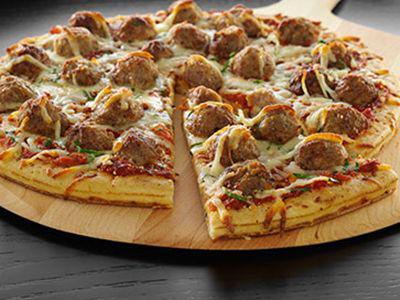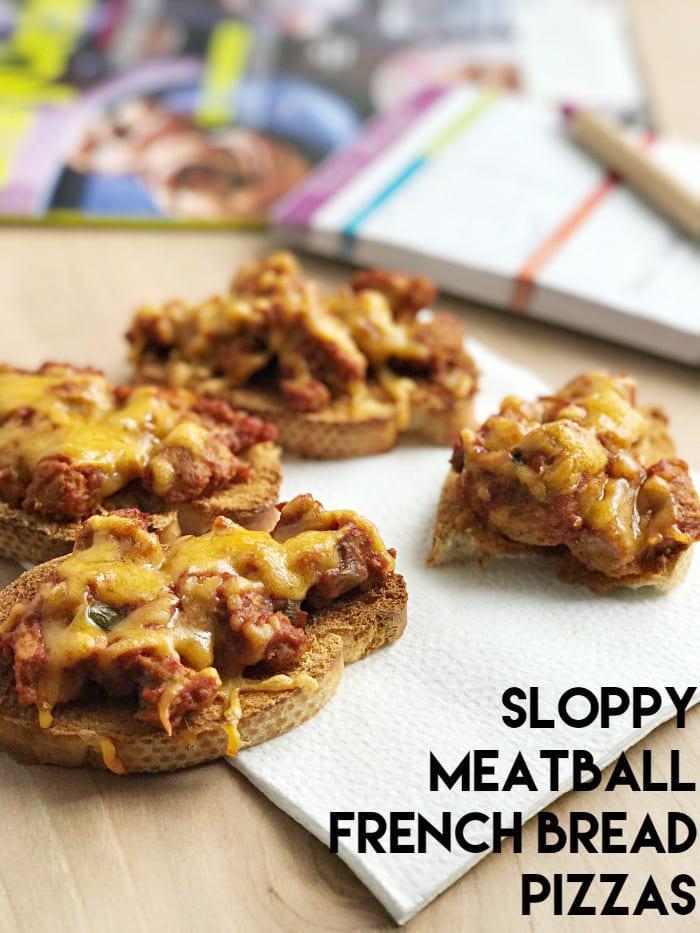The first image is the image on the left, the second image is the image on the right. Examine the images to the left and right. Is the description "The left image shows a round pizza topped with meatballs, and the right image shows individual 'pizzas' with topping on bread." accurate? Answer yes or no. Yes. The first image is the image on the left, the second image is the image on the right. Assess this claim about the two images: "The pizza in both images is french bread pizza.". Correct or not? Answer yes or no. No. 